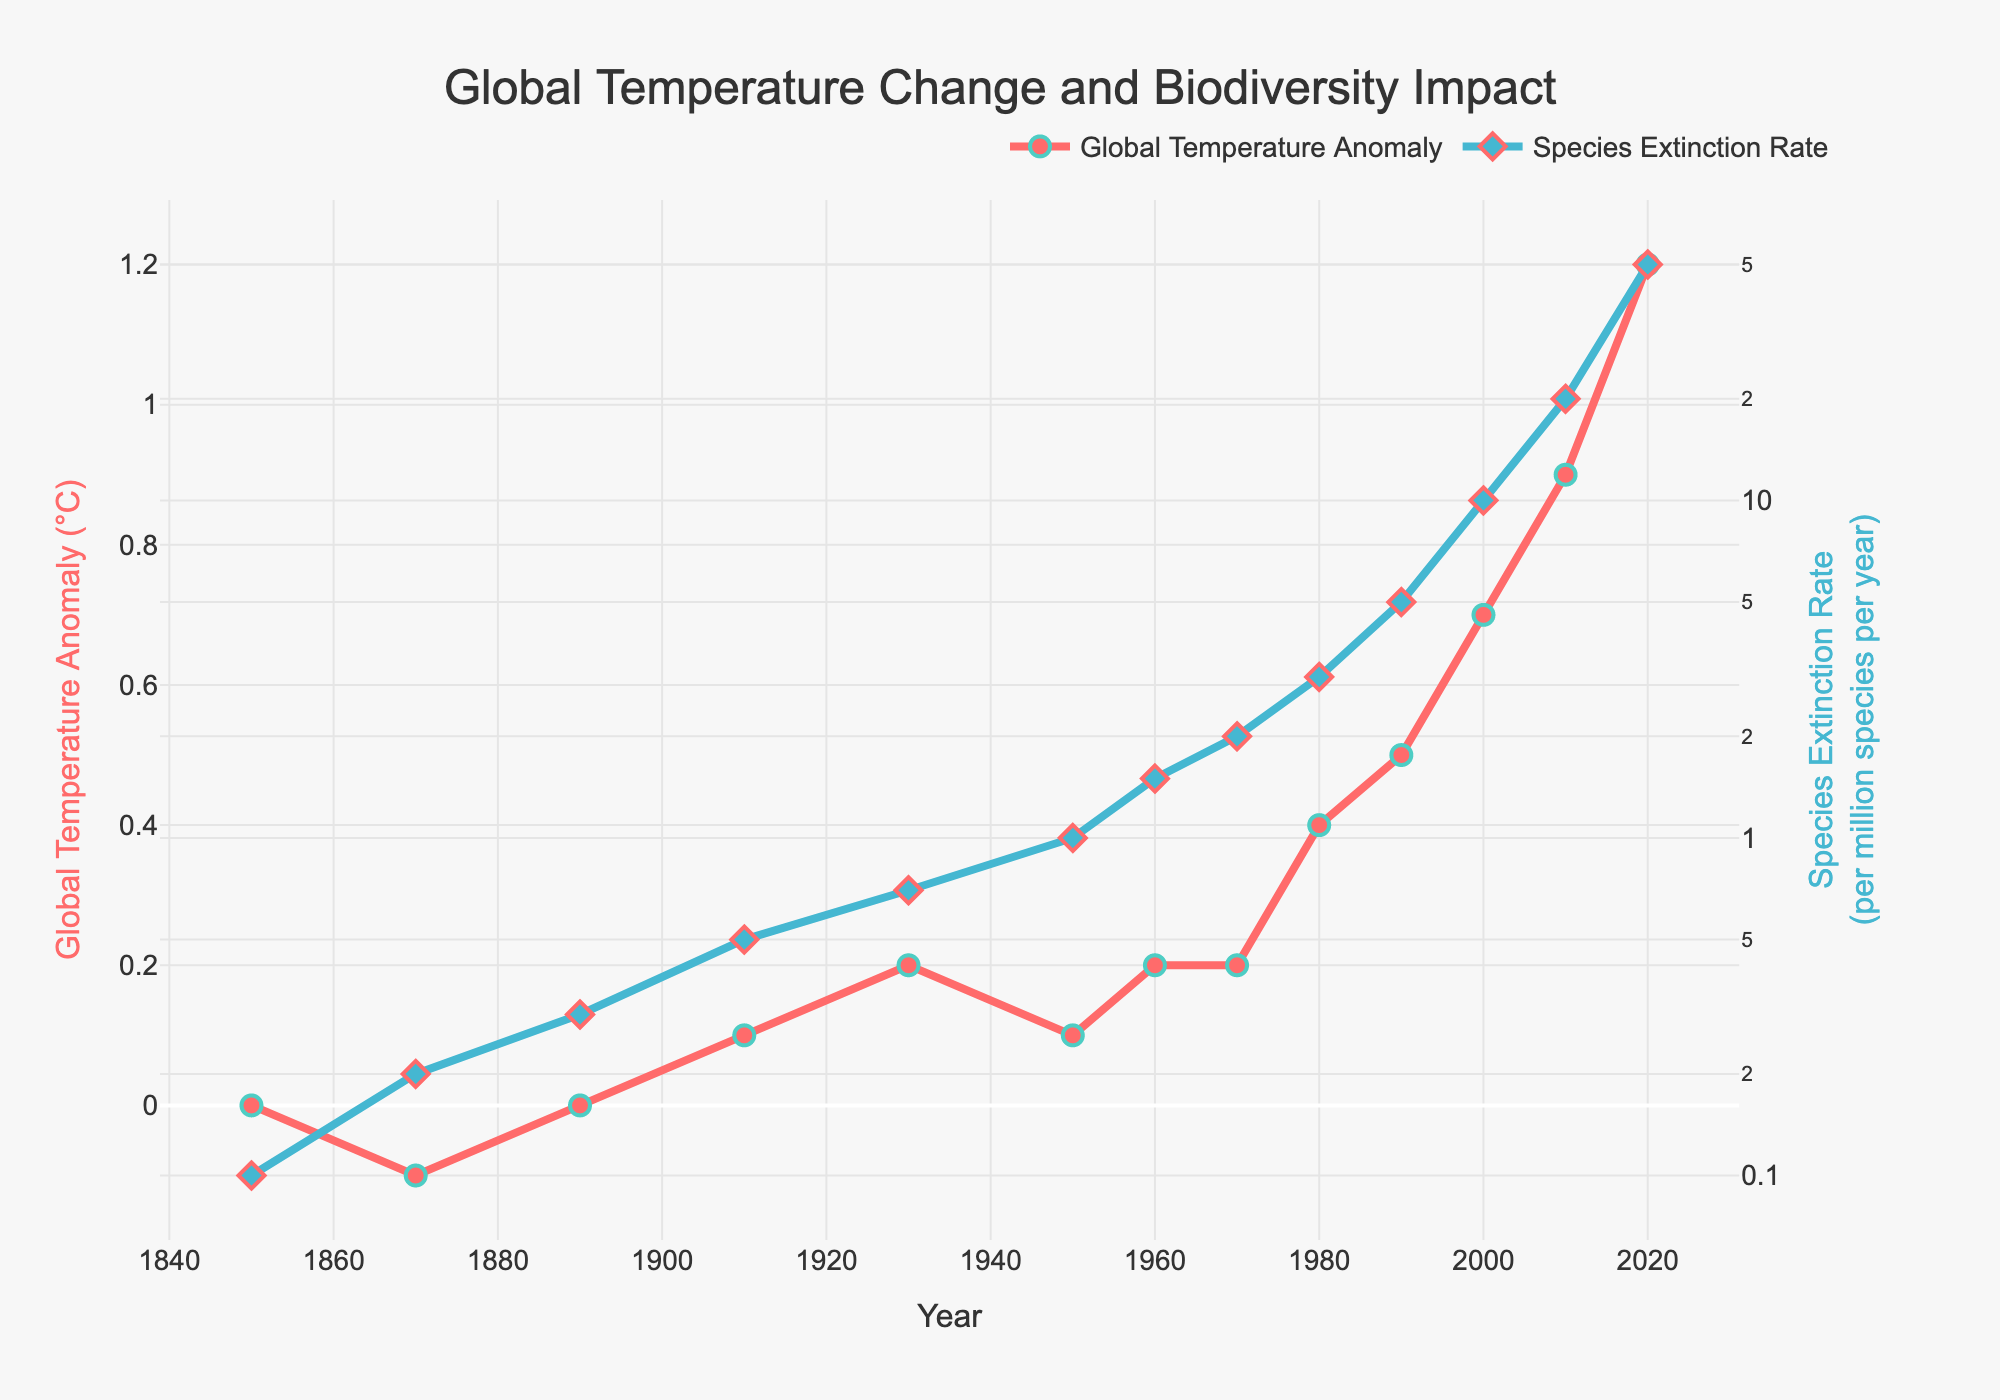What is the trend in global temperature anomaly from 1850 to 2020? The overall trend in the global temperature anomaly from 1850 to 2020 is an upward increase. This is illustrated by the line plot where the anomaly values start at 0.0 °C in 1850 and rise to 1.2 °C in 2020.
Answer: Upward increase Compare the species extinction rate between the years 1910 and 2020. In 1910, the species extinction rate is 0.5 per million species per year, while in 2020 it is 50.0 per million species per year. The extinction rate in 2020 is significantly higher than in 1910.
Answer: The rate is significantly higher in 2020 What can be observed about the species extinction rate between 1980 and 2000? From 1980 to 2000, the species extinction rate increases from 3.0 to 10.0 per million species per year, indicating a rise over this period.
Answer: It increased What is the difference in the global temperature anomaly between 1950 and 2020? The global temperature anomaly in 1950 is 0.1 °C, and in 2020 it is 1.2 °C. The difference is 1.2 - 0.1 = 1.1 °C.
Answer: 1.1 °C How does the global temperature anomaly correlate with the species extinction rate over the years? Both the global temperature anomaly and the species extinction rate show increasing trends over the years. As the global temperature anomaly rises, the species extinction rate also increases, suggesting a positive correlation between the two.
Answer: Positive correlation What was the maximum global temperature anomaly observed, and in which year did it occur? The maximum global temperature anomaly observed is 1.2 °C, which occurred in the year 2020.
Answer: 1.2 °C in 2020 Between which consecutive decades did the species extinction rate see the highest increase? The highest increase in the species extinction rate between consecutive decades occurs between 2000 and 2010, where the rate jumps from 10.0 to 20.0 per million species per year.
Answer: Between 2000 and 2010 What is the average global temperature anomaly from 1850 to 2020? To find the average, sum the anomalies: 0.0 + (-0.1) + 0.0 + 0.1 + 0.2 + 0.1 + 0.2 + 0.2 + 0.4 + 0.5 + 0.7 + 0.9 + 1.2 = 4.2. Divide by the number of years: 4.2 / 13 = approximate 0.323 °C.
Answer: Approx. 0.323 °C Is the rise in species extinction rate more pronounced in the latter half of the period (1950-2020) compared to the first half (1850-1950)? Compare the increase in extinction rate: From 1850 to 1950 (first half), it goes from 0.1 to 1.0, an increase of 0.9. From 1950 to 2020 (second half), it goes from 1.0 to 50.0, an increase of 49.0. The latter half shows a much more pronounced rise.
Answer: Yes, more pronounced in the latter half 